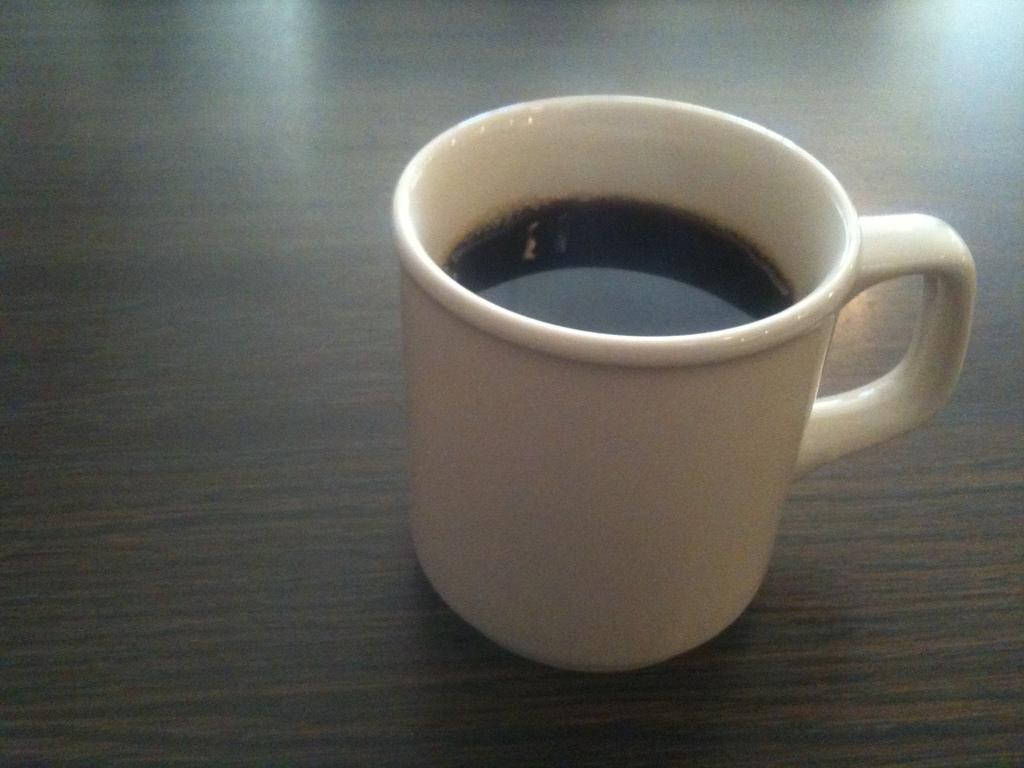Could you give a brief overview of what you see in this image? In this image I can see a tea cup is placed on a wooden surface. 